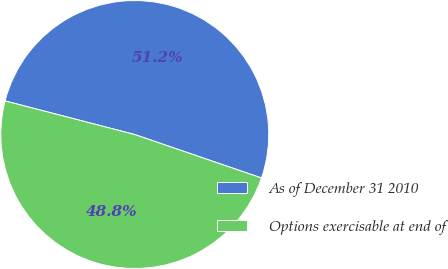Convert chart to OTSL. <chart><loc_0><loc_0><loc_500><loc_500><pie_chart><fcel>As of December 31 2010<fcel>Options exercisable at end of<nl><fcel>51.22%<fcel>48.78%<nl></chart> 